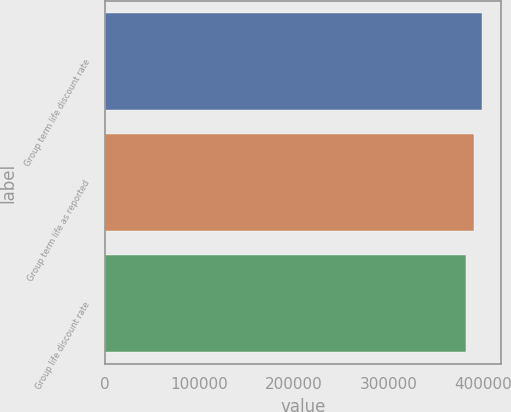<chart> <loc_0><loc_0><loc_500><loc_500><bar_chart><fcel>Group term life discount rate<fcel>Group term life as reported<fcel>Group life discount rate<nl><fcel>398440<fcel>389994<fcel>382191<nl></chart> 